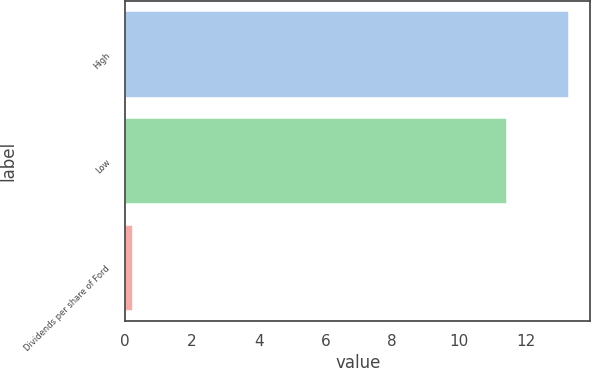Convert chart. <chart><loc_0><loc_0><loc_500><loc_500><bar_chart><fcel>High<fcel>Low<fcel>Dividends per share of Ford<nl><fcel>13.27<fcel>11.41<fcel>0.2<nl></chart> 